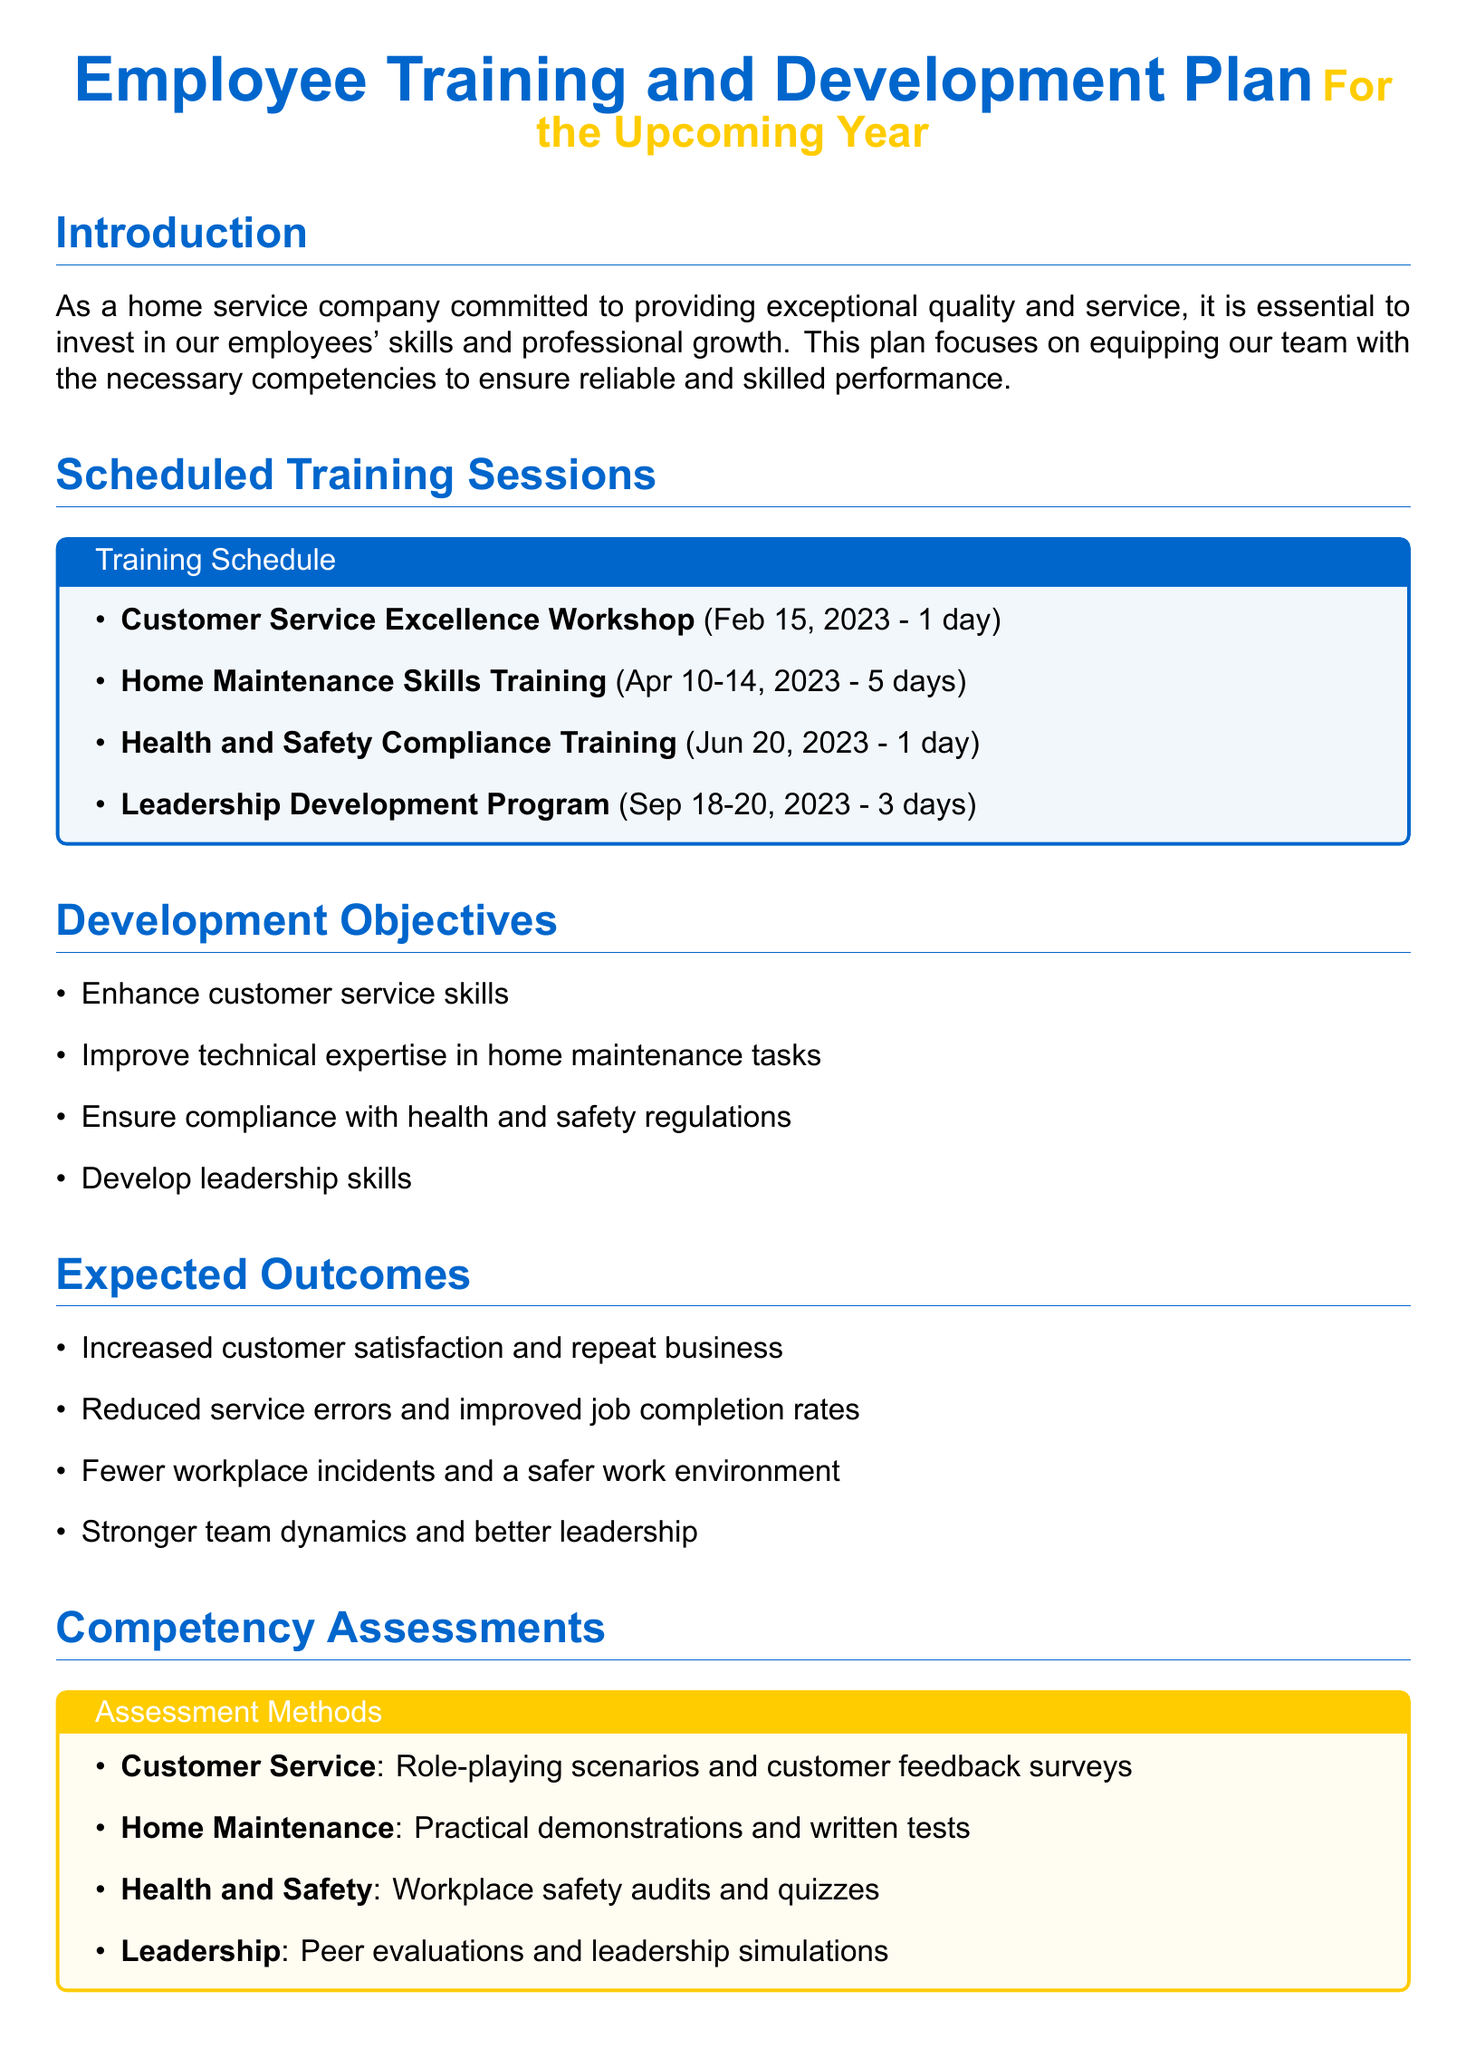What is the date of the Customer Service Excellence Workshop? The date for the Customer Service Excellence Workshop is mentioned in the training schedule section.
Answer: Feb 15, 2023 How many days is the Home Maintenance Skills Training scheduled for? The duration of the Home Maintenance Skills Training is specified in the training schedule section.
Answer: 5 days What is one of the development objectives listed in the document? The development objectives listed in the document include various skills that employees should enhance or improve.
Answer: Enhance customer service skills Which training session focuses on health and safety compliance? The training session related to health and safety compliance is listed in the scheduled training sessions.
Answer: Health and Safety Compliance Training What method is used for competency assessment in Customer Service? The competency assessment method for Customer Service is described in the competency assessments section of the document.
Answer: Role-playing scenarios and customer feedback surveys What is the frequency of progress tracking mentioned in the document? The frequency for progress tracking is noted under the progress tracking section.
Answer: Quarterly Who is responsible for conducting evaluations according to the progress tracking plan? The responsible party for conducting evaluations is identified in the responsibilities section of the progress tracking plan.
Answer: HR professional What is an expected outcome of the training plan? The expected outcomes of the training plan describe the benefits anticipated from the training sessions.
Answer: Increased customer satisfaction and repeat business 